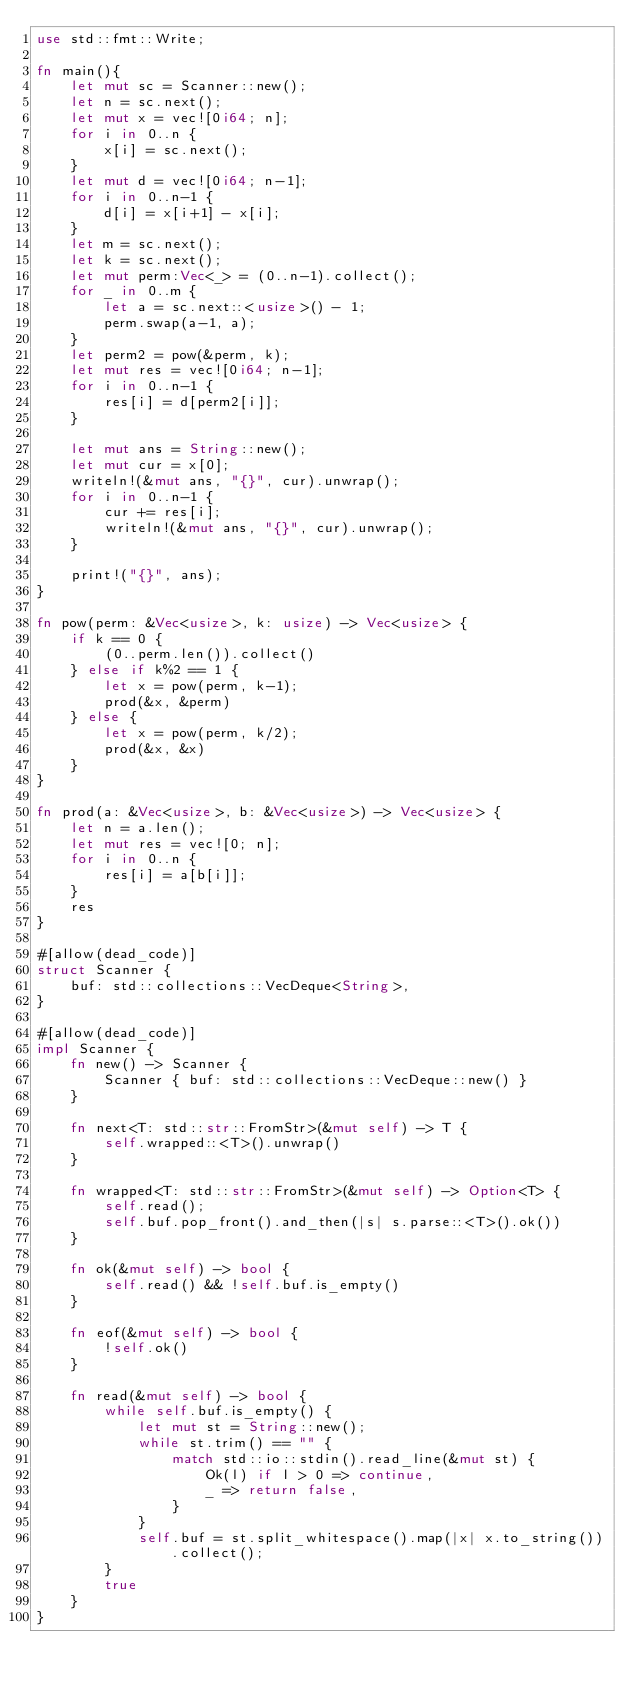<code> <loc_0><loc_0><loc_500><loc_500><_Rust_>use std::fmt::Write;

fn main(){
    let mut sc = Scanner::new();
    let n = sc.next();
    let mut x = vec![0i64; n];
    for i in 0..n {
        x[i] = sc.next();
    }
    let mut d = vec![0i64; n-1];
    for i in 0..n-1 {
        d[i] = x[i+1] - x[i];
    }
    let m = sc.next();
    let k = sc.next();
    let mut perm:Vec<_> = (0..n-1).collect();
    for _ in 0..m {
        let a = sc.next::<usize>() - 1;
        perm.swap(a-1, a);
    }
    let perm2 = pow(&perm, k);
    let mut res = vec![0i64; n-1];
    for i in 0..n-1 {
        res[i] = d[perm2[i]];
    }
    
    let mut ans = String::new();
    let mut cur = x[0];
    writeln!(&mut ans, "{}", cur).unwrap();
    for i in 0..n-1 {
        cur += res[i];
        writeln!(&mut ans, "{}", cur).unwrap();
    }
    
    print!("{}", ans);
}

fn pow(perm: &Vec<usize>, k: usize) -> Vec<usize> {
    if k == 0 {
        (0..perm.len()).collect()
    } else if k%2 == 1 {
        let x = pow(perm, k-1);
        prod(&x, &perm)
    } else {
        let x = pow(perm, k/2);
        prod(&x, &x)
    }
}

fn prod(a: &Vec<usize>, b: &Vec<usize>) -> Vec<usize> {
    let n = a.len();
    let mut res = vec![0; n];
    for i in 0..n {
        res[i] = a[b[i]];
    }
    res
}

#[allow(dead_code)]
struct Scanner {
    buf: std::collections::VecDeque<String>,
}

#[allow(dead_code)]
impl Scanner {
    fn new() -> Scanner {
        Scanner { buf: std::collections::VecDeque::new() }
    }
    
    fn next<T: std::str::FromStr>(&mut self) -> T {
        self.wrapped::<T>().unwrap()
    }
    
    fn wrapped<T: std::str::FromStr>(&mut self) -> Option<T> {
        self.read();
        self.buf.pop_front().and_then(|s| s.parse::<T>().ok())
    }
    
    fn ok(&mut self) -> bool {
        self.read() && !self.buf.is_empty()
    }
    
    fn eof(&mut self) -> bool {
        !self.ok()
    }
    
    fn read(&mut self) -> bool {
        while self.buf.is_empty() {
            let mut st = String::new();
            while st.trim() == "" {
                match std::io::stdin().read_line(&mut st) {
                    Ok(l) if l > 0 => continue,
                    _ => return false,
                }
            }
            self.buf = st.split_whitespace().map(|x| x.to_string()).collect();
        }
        true
    }
}
</code> 